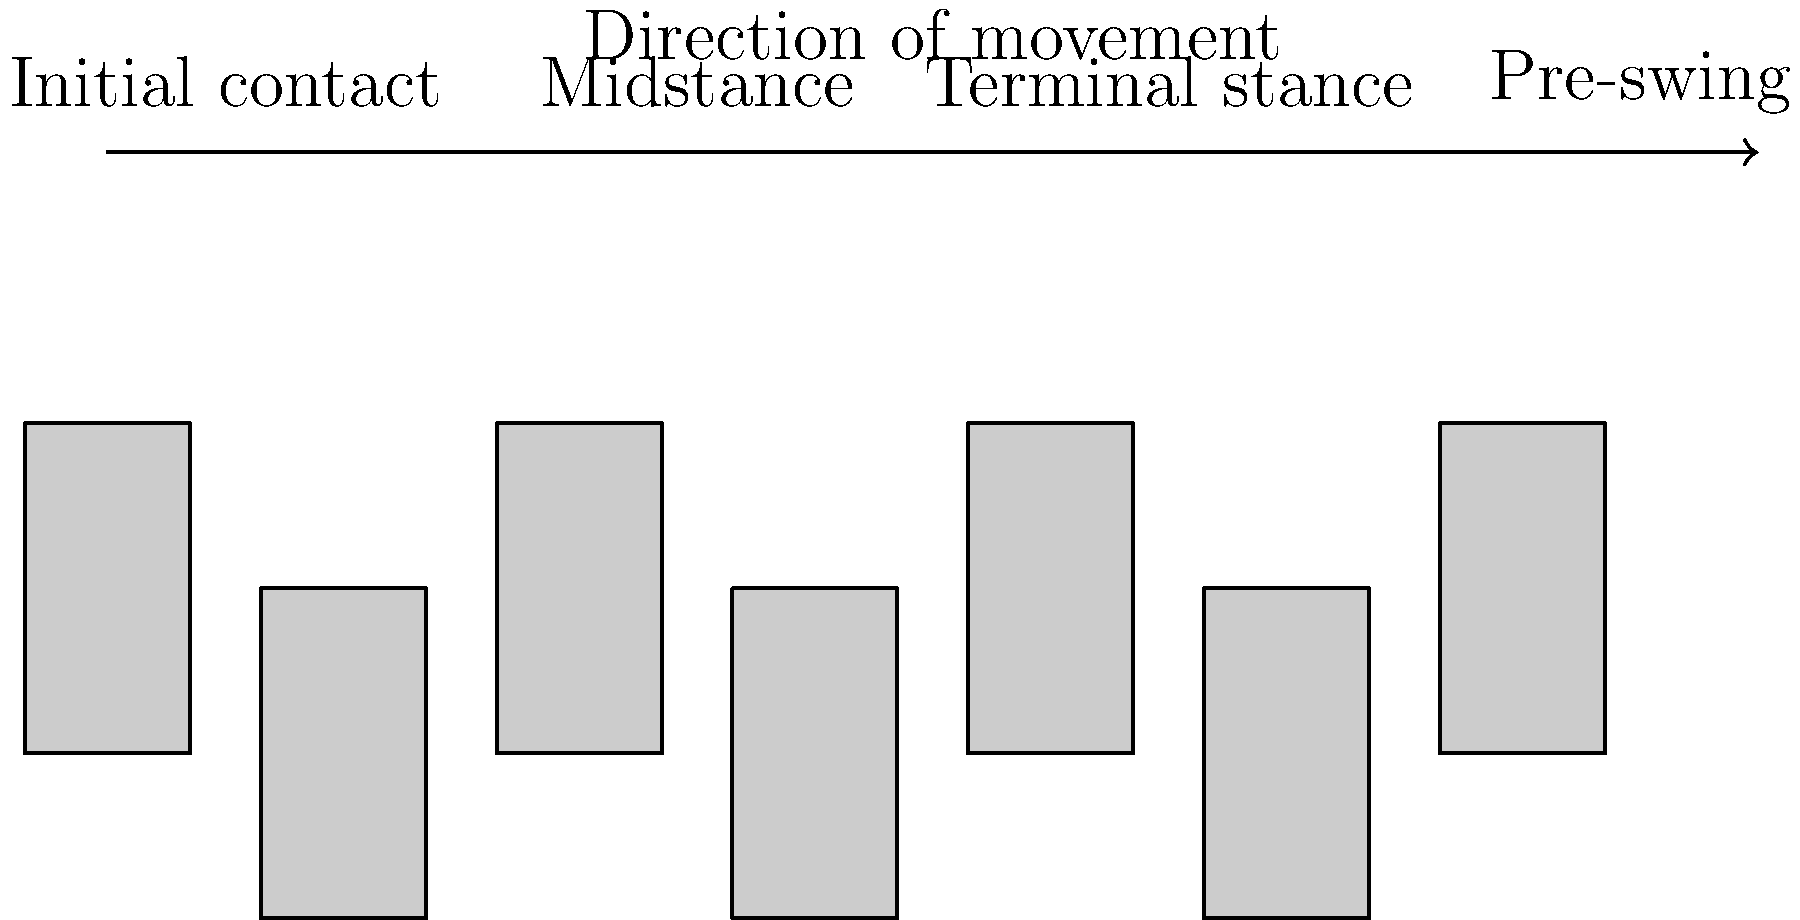In the context of overcoming physical challenges, identify the phase of the gait cycle where the body's center of mass is at its highest point, providing the most stability. How might this relate to building a strong foundation in both personal recovery and business growth? To answer this question, let's break down the gait cycle and its phases:

1. Initial contact: The heel of the leading foot touches the ground.
2. Midstance: The foot is flat on the ground, supporting the full body weight.
3. Terminal stance: The heel begins to lift off the ground.
4. Pre-swing: The toe pushes off the ground, propelling the body forward.

The body's center of mass is at its highest point during the midstance phase. This is because:

a) The supporting leg is fully extended.
b) The body is balanced over a single leg.
c) The other leg is swinging through, preparing for the next step.

During midstance, the body achieves maximum stability due to:
- Full foot contact with the ground
- Vertical alignment of the body over the supporting leg
- Balanced weight distribution

Relating this to personal recovery and business growth:
1. Stability in midstance represents a strong foundation in recovery.
2. This stable position allows for assessment of the situation and planning next steps.
3. Just as midstance provides a moment of balance before moving forward, recovery and business growth require periods of stability to consolidate progress.
4. The ability to maintain balance on one leg symbolizes resilience and adaptability in facing challenges.
5. The cyclical nature of gait mirrors the ongoing process of personal growth and business development.
Answer: Midstance 